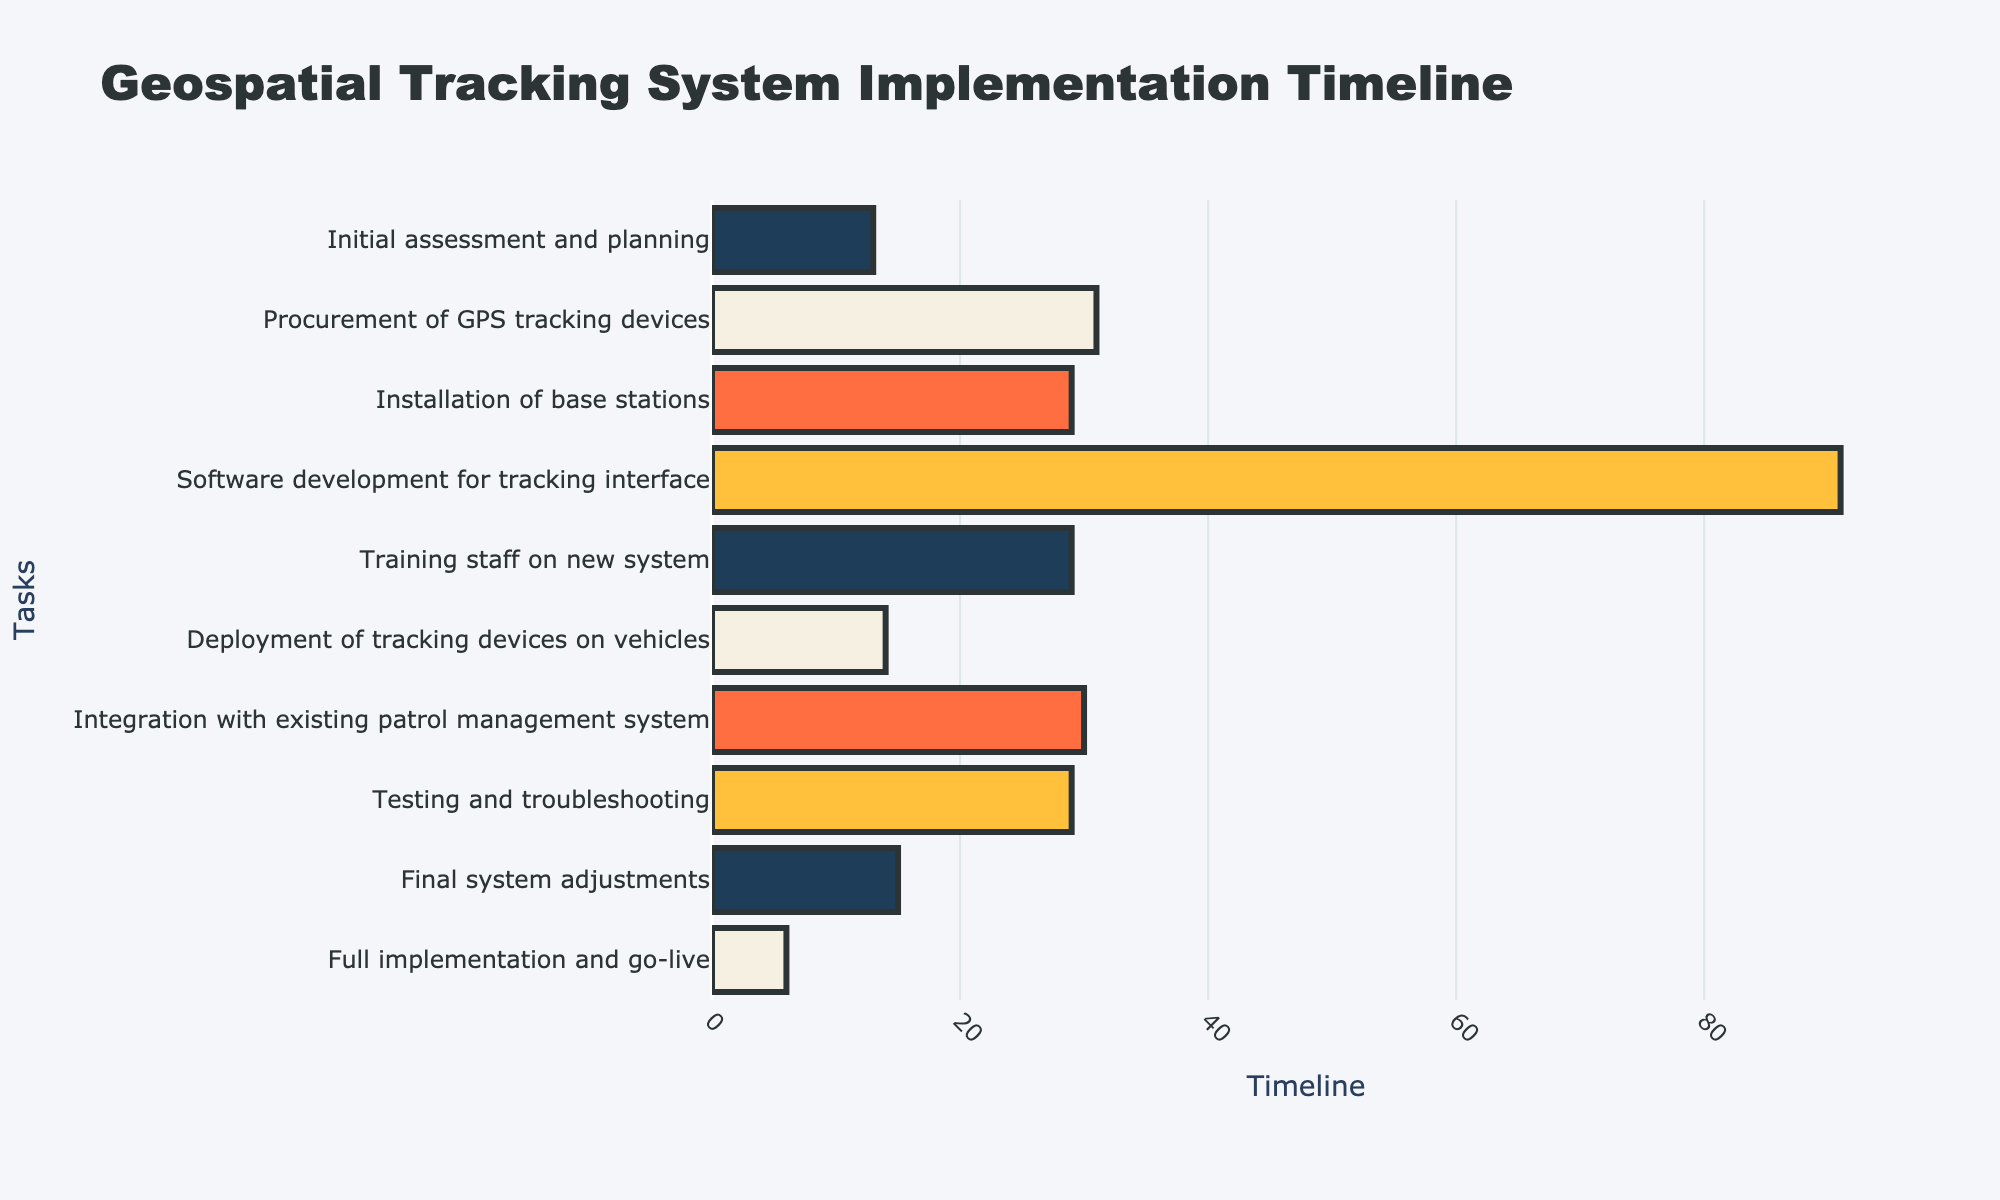What is the title of the Gantt chart? The title is usually displayed at the top of the chart and describes the main topic or purpose of the figure.
Answer: Geospatial Tracking System Implementation Timeline What are the starting and ending dates for the task "Procurement of GPS tracking devices"? Find the row corresponding to "Procurement of GPS tracking devices" and note the starting and ending dates. This information will be provided in the hover text or directly on the chart.
Answer: 2023-05-15 to 2023-06-15 How long does the "Software development for tracking interface" task take? Subtract the starting date from the ending date for the task labeled "Software development for tracking interface." The duration is the number of days between these two dates.
Answer: 92 days Which task has the shortest duration and what is it? Compare the duration of all tasks by looking at their corresponding bars in the Gantt chart. The task with the shortest bar has the shortest duration.
Answer: Deployment of tracking devices on vehicles What tasks are overlapping with "Installation of base stations"? Identify the time range for "Installation of base stations" and see which other tasks' time ranges overlap with it.
Answer: Software development for tracking interface Are there any tasks that start on the same day? If yes, what are they? Look for tasks that share the same starting date by comparing the start dates of all tasks.
Answer: None Which task finishes last, and when does it end? Identify the task with the latest end date by comparing the end dates of all tasks.
Answer: Full implementation and go-live, 2024-01-07 How many tasks are scheduled to take place in September 2023? Check which tasks have their start or end dates within September 2023. Count the number of such tasks.
Answer: 1 task What is the total time span for the entire project from start to end? Compare the earliest start date and the latest end date of all tasks. Subtract the earliest start date from the latest end date to get the total time span.
Answer: May 1st, 2023 to January 7th, 2024 Considering "Final system adjustments" overlaps with only one other task, which task is it? Examine the time range for "Final system adjustments" and see which task timeline overlaps with it.
Answer: Testing and troubleshooting 